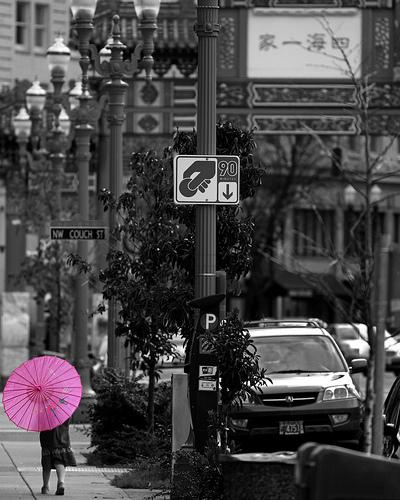Point out an unusual feature or characteristic of an object in the scene. The license plate on a car's front has non-English characters, making it unique in the image. Please describe the weather conditions suggested by the image. The presence of umbrellas suggests that it could be a rainy day in the image. Identify a detail regarding the environment or surroundings of the image. Several light poles are lined up along the street, providing illumination for the area. Talk about an accessory that complements someone's attire in the image. A woman is wearing a dress, and she carries a matching pink parasol with a floral design. Find an object in the picture that serves a specific purpose or function. A lamp post with a parking meter attached serves both lighting and parking payment purposes. What is the dominant mode of transportation depicted in the image? An SUV parked on the road, implying that cars are the primary mode of transportation here. Describe an activity or action that someone is engaged in within the image. A woman is walking down the sidewalk carrying a pink parasol with a floral design. Describe an aspect of cultural or linguistic diversity in the image. A sign in the image displays Asian writing, highlighting cultural diversity in the area. Explain a notable street sign in the picture and its relevance to the scene. A sign on the pole says NW Couch St, indicating the location where the scene takes place. Mention the most eye-catching object in the image and its distinctive feature. A bright purple umbrella stands out in the image with its vivid color. 